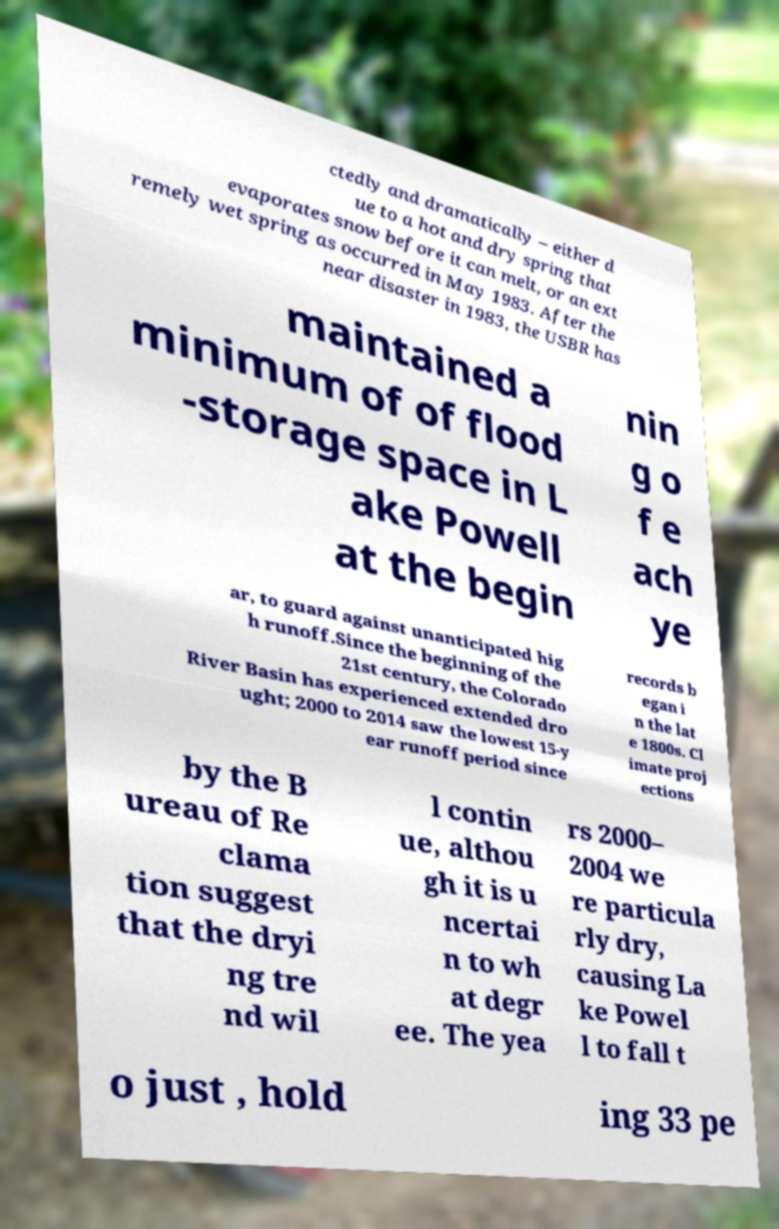Can you accurately transcribe the text from the provided image for me? ctedly and dramatically – either d ue to a hot and dry spring that evaporates snow before it can melt, or an ext remely wet spring as occurred in May 1983. After the near disaster in 1983, the USBR has maintained a minimum of of flood -storage space in L ake Powell at the begin nin g o f e ach ye ar, to guard against unanticipated hig h runoff.Since the beginning of the 21st century, the Colorado River Basin has experienced extended dro ught; 2000 to 2014 saw the lowest 15-y ear runoff period since records b egan i n the lat e 1800s. Cl imate proj ections by the B ureau of Re clama tion suggest that the dryi ng tre nd wil l contin ue, althou gh it is u ncertai n to wh at degr ee. The yea rs 2000– 2004 we re particula rly dry, causing La ke Powel l to fall t o just , hold ing 33 pe 